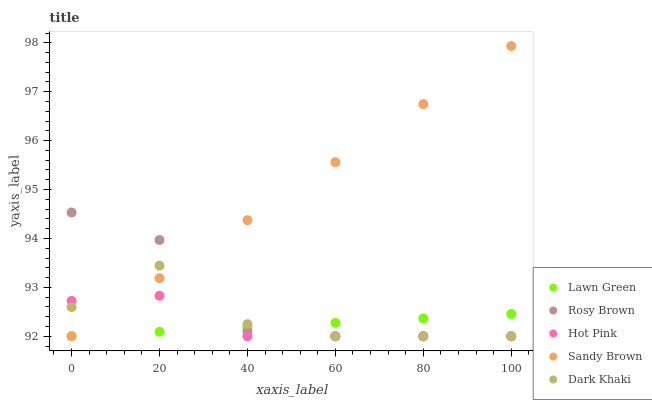Does Lawn Green have the minimum area under the curve?
Answer yes or no. Yes. Does Sandy Brown have the maximum area under the curve?
Answer yes or no. Yes. Does Rosy Brown have the minimum area under the curve?
Answer yes or no. No. Does Rosy Brown have the maximum area under the curve?
Answer yes or no. No. Is Sandy Brown the smoothest?
Answer yes or no. Yes. Is Dark Khaki the roughest?
Answer yes or no. Yes. Is Lawn Green the smoothest?
Answer yes or no. No. Is Lawn Green the roughest?
Answer yes or no. No. Does Dark Khaki have the lowest value?
Answer yes or no. Yes. Does Sandy Brown have the highest value?
Answer yes or no. Yes. Does Rosy Brown have the highest value?
Answer yes or no. No. Does Sandy Brown intersect Rosy Brown?
Answer yes or no. Yes. Is Sandy Brown less than Rosy Brown?
Answer yes or no. No. Is Sandy Brown greater than Rosy Brown?
Answer yes or no. No. 